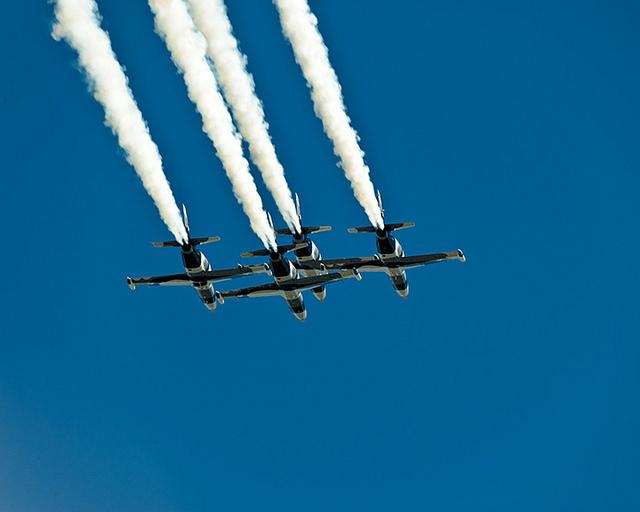How many jet planes are flying together in the sky with military formation? Please explain your reasoning. four. There are three layers. there is one plane in the top layer, two in the middle layer, and one in the bottom layer. 